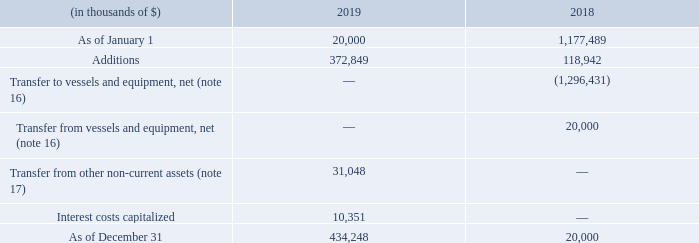15. ASSET UNDER DEVELOPMENT
In May 2018, upon the completion of the Hilli FLNG conversion and commissioning, we reclassified $1,296 million to "Vessels and equipment, net" in our consolidated balance sheet as of December 31, 2018.
In December 2018, we entered into agreements with Keppel for the conversion of the Gimi to a FLNG and consequently reclassified the carrying value of the Gimi of $20.0 million from "Vessels and equipment, net" to "Asset under development".
In February 2019, Golar entered into an agreement with BP for the employment of a FLNG unit, Gimi, to service the Greater Tortue Ahmeyim project for a 20-year period expected to commence in 2022.
In April 2019, we issued the shipyard with a Final Notice to Proceed with conversion works that had been initiated under the Limited Notice to Proceed. We also completed the sale of 30% of the total issued ordinary share capital of Gimi MS Corp to First FLNG Holdings (see note 5). The estimated conversion cost of the Gimi is approximately $1.3 billion.
What was the reason for entering into agreements with Keppel in 2018? For the conversion of the gimi to a flng. Which years did Golar enter into agreements with companies like Keppel and BP respectively? 2018, 2019. What was the conversion cost of the Gimi? $1.3 billion. Which year was the asset under development as of January 1 higher? 1,177,489 > 20,000
Answer: 2018. What was the change in additions between 2018 and 2019?
Answer scale should be: thousand. 372,849 - 118,942 
Answer: 253907. What was the percentage change in asset under development as of December 31 between 2018 and 2019?
Answer scale should be: percent. (434,248 - 20,000)/20,000 
Answer: 2071.24. 